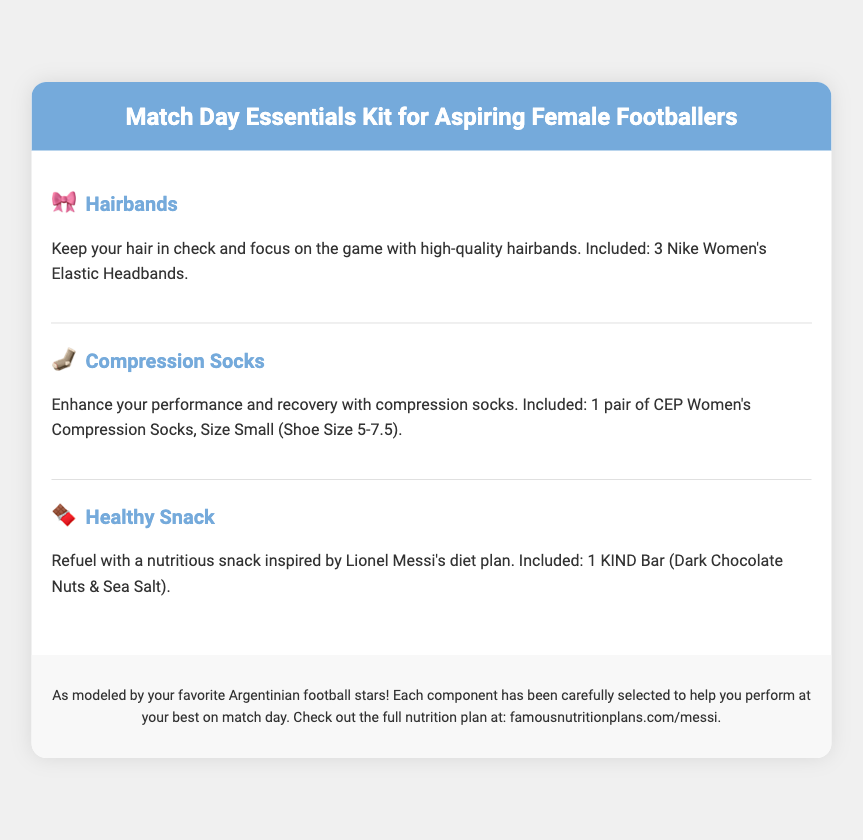what is included in the hairbands section? The hairbands section specifies that 3 Nike Women's Elastic Headbands are included.
Answer: 3 Nike Women's Elastic Headbands what type of socks are included? The document states that 1 pair of CEP Women's Compression Socks is included.
Answer: 1 pair of CEP Women's Compression Socks what is the size of the compression socks? The compression socks are specified to be Size Small (Shoe Size 5-7.5).
Answer: Size Small (Shoe Size 5-7.5) which healthy snack is mentioned? The healthy snack indicated in the document is a KIND Bar (Dark Chocolate Nuts & Sea Salt).
Answer: KIND Bar (Dark Chocolate Nuts & Sea Salt) who is the healthy snack inspired by? The healthy snack is inspired by Lionel Messi's diet plan.
Answer: Lionel Messi how many sections are in the document? The document includes three sections: Hairbands, Compression Socks, and Healthy Snack.
Answer: Three sections what purpose do the hairbands serve? The purpose of the hairbands is to keep your hair in check while focusing on the game.
Answer: Keep your hair in check what is the main aim of the kit? The main aim of the kit is to help aspiring female footballers perform at their best on match day.
Answer: Perform at their best where can you find the full nutrition plan? The document provides a URL to find the full nutrition plan at famousnutritionplans.com/messi.
Answer: famousnutritionplans.com/messi 